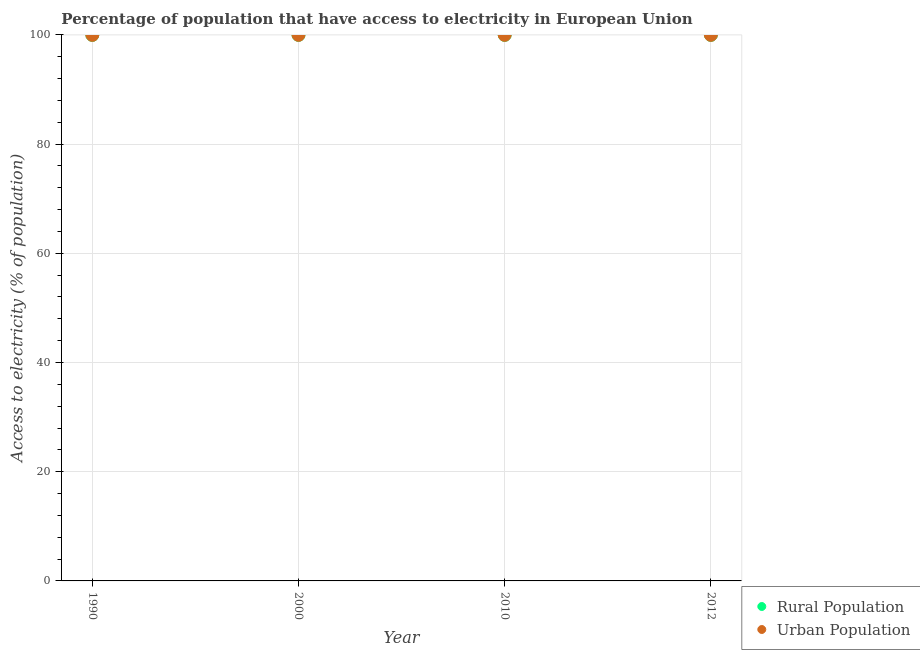Is the number of dotlines equal to the number of legend labels?
Your response must be concise. Yes. What is the percentage of rural population having access to electricity in 1990?
Offer a terse response. 99.99. Across all years, what is the minimum percentage of urban population having access to electricity?
Give a very brief answer. 100. What is the total percentage of rural population having access to electricity in the graph?
Provide a short and direct response. 399.99. What is the difference between the percentage of urban population having access to electricity in 2000 and that in 2010?
Make the answer very short. 0. What is the difference between the percentage of rural population having access to electricity in 2010 and the percentage of urban population having access to electricity in 2000?
Provide a short and direct response. 0. What is the average percentage of rural population having access to electricity per year?
Offer a terse response. 100. In the year 1990, what is the difference between the percentage of urban population having access to electricity and percentage of rural population having access to electricity?
Offer a very short reply. 0. In how many years, is the percentage of urban population having access to electricity greater than 48 %?
Your answer should be compact. 4. What is the ratio of the percentage of rural population having access to electricity in 1990 to that in 2012?
Provide a short and direct response. 1. Is the percentage of urban population having access to electricity in 1990 less than that in 2010?
Provide a succinct answer. Yes. What is the difference between the highest and the second highest percentage of urban population having access to electricity?
Ensure brevity in your answer.  0. What is the difference between the highest and the lowest percentage of urban population having access to electricity?
Provide a succinct answer. 0. Does the percentage of rural population having access to electricity monotonically increase over the years?
Offer a terse response. No. Is the percentage of urban population having access to electricity strictly less than the percentage of rural population having access to electricity over the years?
Provide a succinct answer. No. How many years are there in the graph?
Your answer should be very brief. 4. What is the difference between two consecutive major ticks on the Y-axis?
Your response must be concise. 20. Are the values on the major ticks of Y-axis written in scientific E-notation?
Keep it short and to the point. No. Does the graph contain grids?
Keep it short and to the point. Yes. Where does the legend appear in the graph?
Offer a terse response. Bottom right. How are the legend labels stacked?
Keep it short and to the point. Vertical. What is the title of the graph?
Offer a terse response. Percentage of population that have access to electricity in European Union. Does "Commercial bank branches" appear as one of the legend labels in the graph?
Keep it short and to the point. No. What is the label or title of the Y-axis?
Your answer should be compact. Access to electricity (% of population). What is the Access to electricity (% of population) of Rural Population in 1990?
Your answer should be compact. 99.99. What is the Access to electricity (% of population) of Urban Population in 1990?
Offer a very short reply. 100. What is the Access to electricity (% of population) of Rural Population in 2010?
Your response must be concise. 100. What is the Access to electricity (% of population) of Urban Population in 2010?
Your answer should be compact. 100. What is the Access to electricity (% of population) in Rural Population in 2012?
Offer a terse response. 100. What is the Access to electricity (% of population) of Urban Population in 2012?
Provide a short and direct response. 100. Across all years, what is the maximum Access to electricity (% of population) of Rural Population?
Offer a very short reply. 100. Across all years, what is the minimum Access to electricity (% of population) in Rural Population?
Ensure brevity in your answer.  99.99. Across all years, what is the minimum Access to electricity (% of population) of Urban Population?
Make the answer very short. 100. What is the total Access to electricity (% of population) in Rural Population in the graph?
Offer a very short reply. 399.99. What is the total Access to electricity (% of population) in Urban Population in the graph?
Offer a terse response. 400. What is the difference between the Access to electricity (% of population) of Rural Population in 1990 and that in 2000?
Offer a very short reply. -0.01. What is the difference between the Access to electricity (% of population) in Urban Population in 1990 and that in 2000?
Your response must be concise. -0.01. What is the difference between the Access to electricity (% of population) in Rural Population in 1990 and that in 2010?
Offer a terse response. -0.01. What is the difference between the Access to electricity (% of population) in Urban Population in 1990 and that in 2010?
Give a very brief answer. -0.01. What is the difference between the Access to electricity (% of population) of Rural Population in 1990 and that in 2012?
Offer a terse response. -0.01. What is the difference between the Access to electricity (% of population) in Urban Population in 1990 and that in 2012?
Your answer should be compact. -0.01. What is the difference between the Access to electricity (% of population) in Urban Population in 2000 and that in 2012?
Provide a short and direct response. 0. What is the difference between the Access to electricity (% of population) in Rural Population in 2010 and that in 2012?
Your answer should be very brief. 0. What is the difference between the Access to electricity (% of population) of Rural Population in 1990 and the Access to electricity (% of population) of Urban Population in 2000?
Offer a terse response. -0.01. What is the difference between the Access to electricity (% of population) in Rural Population in 1990 and the Access to electricity (% of population) in Urban Population in 2010?
Keep it short and to the point. -0.01. What is the difference between the Access to electricity (% of population) in Rural Population in 1990 and the Access to electricity (% of population) in Urban Population in 2012?
Provide a succinct answer. -0.01. What is the difference between the Access to electricity (% of population) in Rural Population in 2000 and the Access to electricity (% of population) in Urban Population in 2010?
Offer a very short reply. 0. What is the difference between the Access to electricity (% of population) in Rural Population in 2000 and the Access to electricity (% of population) in Urban Population in 2012?
Offer a very short reply. 0. What is the average Access to electricity (% of population) of Rural Population per year?
Your response must be concise. 100. What is the average Access to electricity (% of population) of Urban Population per year?
Your answer should be compact. 100. In the year 1990, what is the difference between the Access to electricity (% of population) of Rural Population and Access to electricity (% of population) of Urban Population?
Provide a short and direct response. -0. In the year 2000, what is the difference between the Access to electricity (% of population) of Rural Population and Access to electricity (% of population) of Urban Population?
Make the answer very short. 0. In the year 2010, what is the difference between the Access to electricity (% of population) of Rural Population and Access to electricity (% of population) of Urban Population?
Offer a terse response. 0. In the year 2012, what is the difference between the Access to electricity (% of population) of Rural Population and Access to electricity (% of population) of Urban Population?
Your response must be concise. 0. What is the ratio of the Access to electricity (% of population) of Rural Population in 1990 to that in 2000?
Offer a terse response. 1. What is the ratio of the Access to electricity (% of population) in Rural Population in 1990 to that in 2010?
Your response must be concise. 1. What is the ratio of the Access to electricity (% of population) of Urban Population in 1990 to that in 2010?
Keep it short and to the point. 1. What is the ratio of the Access to electricity (% of population) of Urban Population in 1990 to that in 2012?
Give a very brief answer. 1. What is the ratio of the Access to electricity (% of population) in Rural Population in 2000 to that in 2010?
Provide a short and direct response. 1. What is the ratio of the Access to electricity (% of population) of Urban Population in 2000 to that in 2010?
Offer a terse response. 1. What is the ratio of the Access to electricity (% of population) of Urban Population in 2010 to that in 2012?
Give a very brief answer. 1. What is the difference between the highest and the second highest Access to electricity (% of population) in Urban Population?
Give a very brief answer. 0. What is the difference between the highest and the lowest Access to electricity (% of population) of Rural Population?
Make the answer very short. 0.01. What is the difference between the highest and the lowest Access to electricity (% of population) in Urban Population?
Keep it short and to the point. 0.01. 